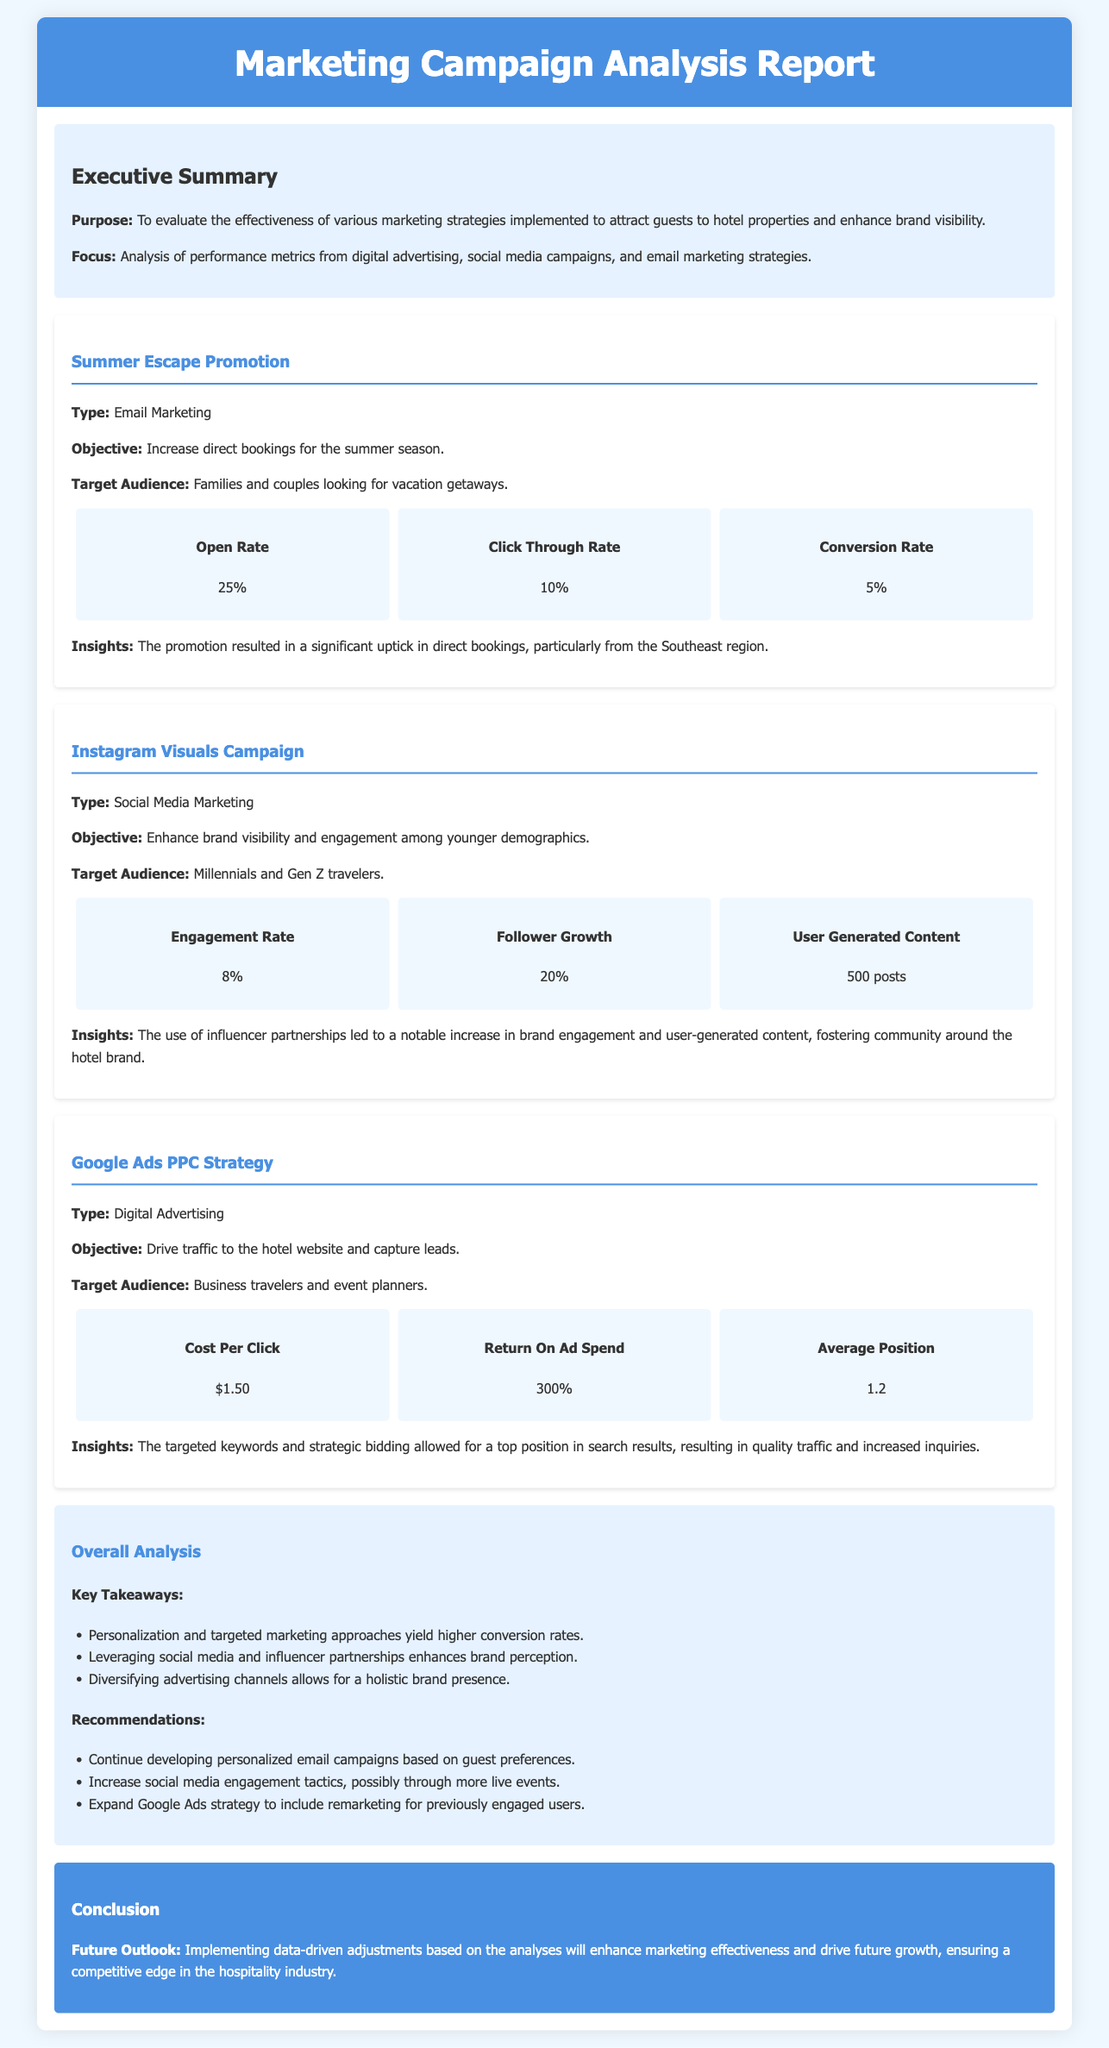What was the open rate of the Summer Escape Promotion? The open rate is a performance metric provided in the campaign details for the Summer Escape Promotion, listed as 25%.
Answer: 25% What is the primary objective of the Instagram Visuals Campaign? The objective for the Instagram Visuals Campaign is mentioned in the campaign section, which is to enhance brand visibility and engagement among younger demographics.
Answer: Enhance brand visibility and engagement What was the engagement rate from the Instagram Visuals Campaign? The engagement rate is displayed in the metrics section of the Instagram Visuals Campaign, which is 8%.
Answer: 8% Which campaign yielded a Return On Ad Spend of 300%? The metric for Return On Ad Spend at 300% is stated under the Google Ads PPC Strategy campaign.
Answer: Google Ads PPC Strategy What are the two main recommendations provided in the Overall Analysis section? Recommendations are listed in the Overall Analysis section, detailing personalized email campaigns and increased social media engagement tactics.
Answer: Personalized email campaigns, increased social media engagement What audience is targeted by the Google Ads PPC Strategy? The target audience for the Google Ads PPC Strategy is explicitly stated in the campaign details, which refers to business travelers and event planners.
Answer: Business travelers and event planners What is the conversion rate for the Summer Escape Promotion? The conversion rate is included in the metrics of the Summer Escape Promotion, which is noted as 5%.
Answer: 5% What does the document suggest for the future outlook? The future outlook is summarized in the Conclusion section, indicating a focus on data-driven adjustments to enhance marketing effectiveness.
Answer: Data-driven adjustments What was the user-generated content metric for the Instagram Visuals Campaign? The number of user-generated content posts is specified in the metrics for the Instagram Visuals Campaign, which is 500 posts.
Answer: 500 posts 